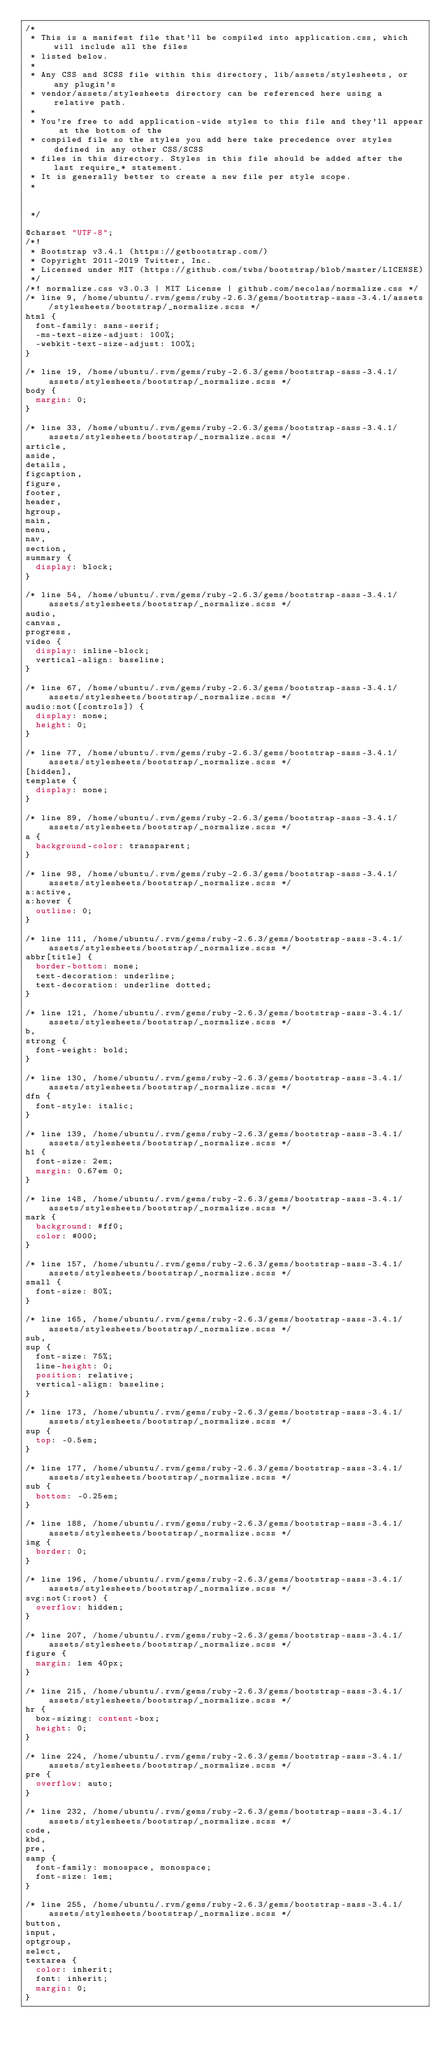Convert code to text. <code><loc_0><loc_0><loc_500><loc_500><_CSS_>/*
 * This is a manifest file that'll be compiled into application.css, which will include all the files
 * listed below.
 *
 * Any CSS and SCSS file within this directory, lib/assets/stylesheets, or any plugin's
 * vendor/assets/stylesheets directory can be referenced here using a relative path.
 *
 * You're free to add application-wide styles to this file and they'll appear at the bottom of the
 * compiled file so the styles you add here take precedence over styles defined in any other CSS/SCSS
 * files in this directory. Styles in this file should be added after the last require_* statement.
 * It is generally better to create a new file per style scope.
 *


 */

@charset "UTF-8";
/*!
 * Bootstrap v3.4.1 (https://getbootstrap.com/)
 * Copyright 2011-2019 Twitter, Inc.
 * Licensed under MIT (https://github.com/twbs/bootstrap/blob/master/LICENSE)
 */
/*! normalize.css v3.0.3 | MIT License | github.com/necolas/normalize.css */
/* line 9, /home/ubuntu/.rvm/gems/ruby-2.6.3/gems/bootstrap-sass-3.4.1/assets/stylesheets/bootstrap/_normalize.scss */
html {
  font-family: sans-serif;
  -ms-text-size-adjust: 100%;
  -webkit-text-size-adjust: 100%;
}

/* line 19, /home/ubuntu/.rvm/gems/ruby-2.6.3/gems/bootstrap-sass-3.4.1/assets/stylesheets/bootstrap/_normalize.scss */
body {
  margin: 0;
}

/* line 33, /home/ubuntu/.rvm/gems/ruby-2.6.3/gems/bootstrap-sass-3.4.1/assets/stylesheets/bootstrap/_normalize.scss */
article,
aside,
details,
figcaption,
figure,
footer,
header,
hgroup,
main,
menu,
nav,
section,
summary {
  display: block;
}

/* line 54, /home/ubuntu/.rvm/gems/ruby-2.6.3/gems/bootstrap-sass-3.4.1/assets/stylesheets/bootstrap/_normalize.scss */
audio,
canvas,
progress,
video {
  display: inline-block;
  vertical-align: baseline;
}

/* line 67, /home/ubuntu/.rvm/gems/ruby-2.6.3/gems/bootstrap-sass-3.4.1/assets/stylesheets/bootstrap/_normalize.scss */
audio:not([controls]) {
  display: none;
  height: 0;
}

/* line 77, /home/ubuntu/.rvm/gems/ruby-2.6.3/gems/bootstrap-sass-3.4.1/assets/stylesheets/bootstrap/_normalize.scss */
[hidden],
template {
  display: none;
}

/* line 89, /home/ubuntu/.rvm/gems/ruby-2.6.3/gems/bootstrap-sass-3.4.1/assets/stylesheets/bootstrap/_normalize.scss */
a {
  background-color: transparent;
}

/* line 98, /home/ubuntu/.rvm/gems/ruby-2.6.3/gems/bootstrap-sass-3.4.1/assets/stylesheets/bootstrap/_normalize.scss */
a:active,
a:hover {
  outline: 0;
}

/* line 111, /home/ubuntu/.rvm/gems/ruby-2.6.3/gems/bootstrap-sass-3.4.1/assets/stylesheets/bootstrap/_normalize.scss */
abbr[title] {
  border-bottom: none;
  text-decoration: underline;
  text-decoration: underline dotted;
}

/* line 121, /home/ubuntu/.rvm/gems/ruby-2.6.3/gems/bootstrap-sass-3.4.1/assets/stylesheets/bootstrap/_normalize.scss */
b,
strong {
  font-weight: bold;
}

/* line 130, /home/ubuntu/.rvm/gems/ruby-2.6.3/gems/bootstrap-sass-3.4.1/assets/stylesheets/bootstrap/_normalize.scss */
dfn {
  font-style: italic;
}

/* line 139, /home/ubuntu/.rvm/gems/ruby-2.6.3/gems/bootstrap-sass-3.4.1/assets/stylesheets/bootstrap/_normalize.scss */
h1 {
  font-size: 2em;
  margin: 0.67em 0;
}

/* line 148, /home/ubuntu/.rvm/gems/ruby-2.6.3/gems/bootstrap-sass-3.4.1/assets/stylesheets/bootstrap/_normalize.scss */
mark {
  background: #ff0;
  color: #000;
}

/* line 157, /home/ubuntu/.rvm/gems/ruby-2.6.3/gems/bootstrap-sass-3.4.1/assets/stylesheets/bootstrap/_normalize.scss */
small {
  font-size: 80%;
}

/* line 165, /home/ubuntu/.rvm/gems/ruby-2.6.3/gems/bootstrap-sass-3.4.1/assets/stylesheets/bootstrap/_normalize.scss */
sub,
sup {
  font-size: 75%;
  line-height: 0;
  position: relative;
  vertical-align: baseline;
}

/* line 173, /home/ubuntu/.rvm/gems/ruby-2.6.3/gems/bootstrap-sass-3.4.1/assets/stylesheets/bootstrap/_normalize.scss */
sup {
  top: -0.5em;
}

/* line 177, /home/ubuntu/.rvm/gems/ruby-2.6.3/gems/bootstrap-sass-3.4.1/assets/stylesheets/bootstrap/_normalize.scss */
sub {
  bottom: -0.25em;
}

/* line 188, /home/ubuntu/.rvm/gems/ruby-2.6.3/gems/bootstrap-sass-3.4.1/assets/stylesheets/bootstrap/_normalize.scss */
img {
  border: 0;
}

/* line 196, /home/ubuntu/.rvm/gems/ruby-2.6.3/gems/bootstrap-sass-3.4.1/assets/stylesheets/bootstrap/_normalize.scss */
svg:not(:root) {
  overflow: hidden;
}

/* line 207, /home/ubuntu/.rvm/gems/ruby-2.6.3/gems/bootstrap-sass-3.4.1/assets/stylesheets/bootstrap/_normalize.scss */
figure {
  margin: 1em 40px;
}

/* line 215, /home/ubuntu/.rvm/gems/ruby-2.6.3/gems/bootstrap-sass-3.4.1/assets/stylesheets/bootstrap/_normalize.scss */
hr {
  box-sizing: content-box;
  height: 0;
}

/* line 224, /home/ubuntu/.rvm/gems/ruby-2.6.3/gems/bootstrap-sass-3.4.1/assets/stylesheets/bootstrap/_normalize.scss */
pre {
  overflow: auto;
}

/* line 232, /home/ubuntu/.rvm/gems/ruby-2.6.3/gems/bootstrap-sass-3.4.1/assets/stylesheets/bootstrap/_normalize.scss */
code,
kbd,
pre,
samp {
  font-family: monospace, monospace;
  font-size: 1em;
}

/* line 255, /home/ubuntu/.rvm/gems/ruby-2.6.3/gems/bootstrap-sass-3.4.1/assets/stylesheets/bootstrap/_normalize.scss */
button,
input,
optgroup,
select,
textarea {
  color: inherit;
  font: inherit;
  margin: 0;
}
</code> 